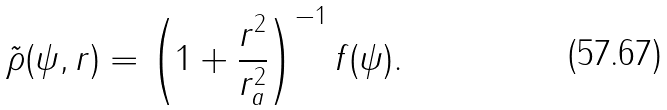<formula> <loc_0><loc_0><loc_500><loc_500>\tilde { \rho } ( \psi , r ) = \left ( 1 + \frac { r ^ { 2 } } { r _ { a } ^ { 2 } } \right ) ^ { - 1 } f ( \psi ) .</formula> 